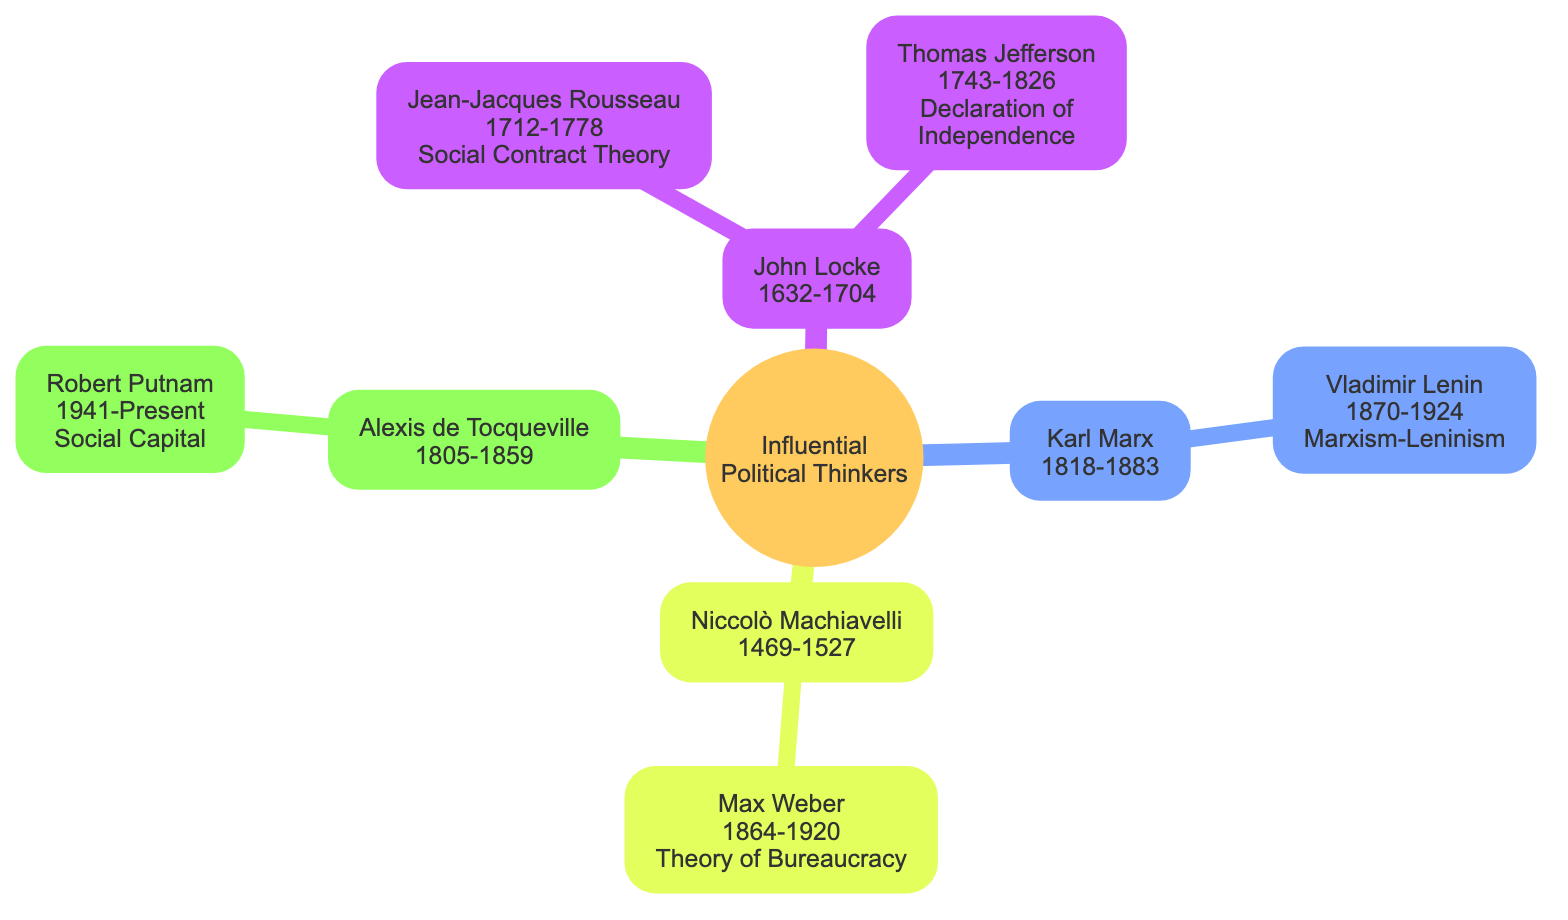What is the time span of John Locke? The node for John Locke in the diagram displays the years he lived, which are from 1632 to 1704. This information is read directly from the node’s details.
Answer: 1632-1704 Who influenced Thomas Jefferson? The diagram shows a direct connection from John Locke to Thomas Jefferson, indicating that John Locke is the thinker who influenced him. This is explicitly stated in the diagram.
Answer: John Locke How many thinkers are influenced by Karl Marx? The diagram has one child node directly under Karl Marx, which is Vladimir Lenin. This indicates a count of how many thinkers were influenced by Marx.
Answer: 1 What is the influence of Jean-Jacques Rousseau? The node for Jean-Jacques Rousseau states "Social Contract Theory" as his area of influence. This information is presented clearly under his name in the diagram.
Answer: Social Contract Theory Who is influenced by Niccolò Machiavelli? In the family tree, Max Weber is shown as the only thinker influenced by Niccolò Machiavelli. The diagram's structure displays this relationship clearly.
Answer: Max Weber Which thinker is associated with the concept of Social Capital? Looking at the diagram, Robert Putnam is mentioned alongside "Social Capital" as his influence, which directly connects him to that concept as presented in the node.
Answer: Robert Putnam Which political thinker lived in the 19th century and influenced others? From the diagram, Alexis de Tocqueville (1805-1859) is the only thinker identified within the 19th century, and he has a direct influence on Robert Putnam.
Answer: Alexis de Tocqueville Who is the earliest political thinker in the diagram? The diagram displays the years of influential political thinkers, and Niccolò Machiavelli, who lived from 1469 to 1527, is the earliest among them. This can be determined by comparing the years listed for each thinker.
Answer: Niccolò Machiavelli How many political thinkers are directly influenced by John Locke? According to the diagram, there are two nodes under John Locke: Jean-Jacques Rousseau and Thomas Jefferson, signifying that he influenced two individuals.
Answer: 2 